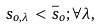<formula> <loc_0><loc_0><loc_500><loc_500>s _ { o , \lambda } < \bar { s } _ { o } ; \forall \lambda ,</formula> 